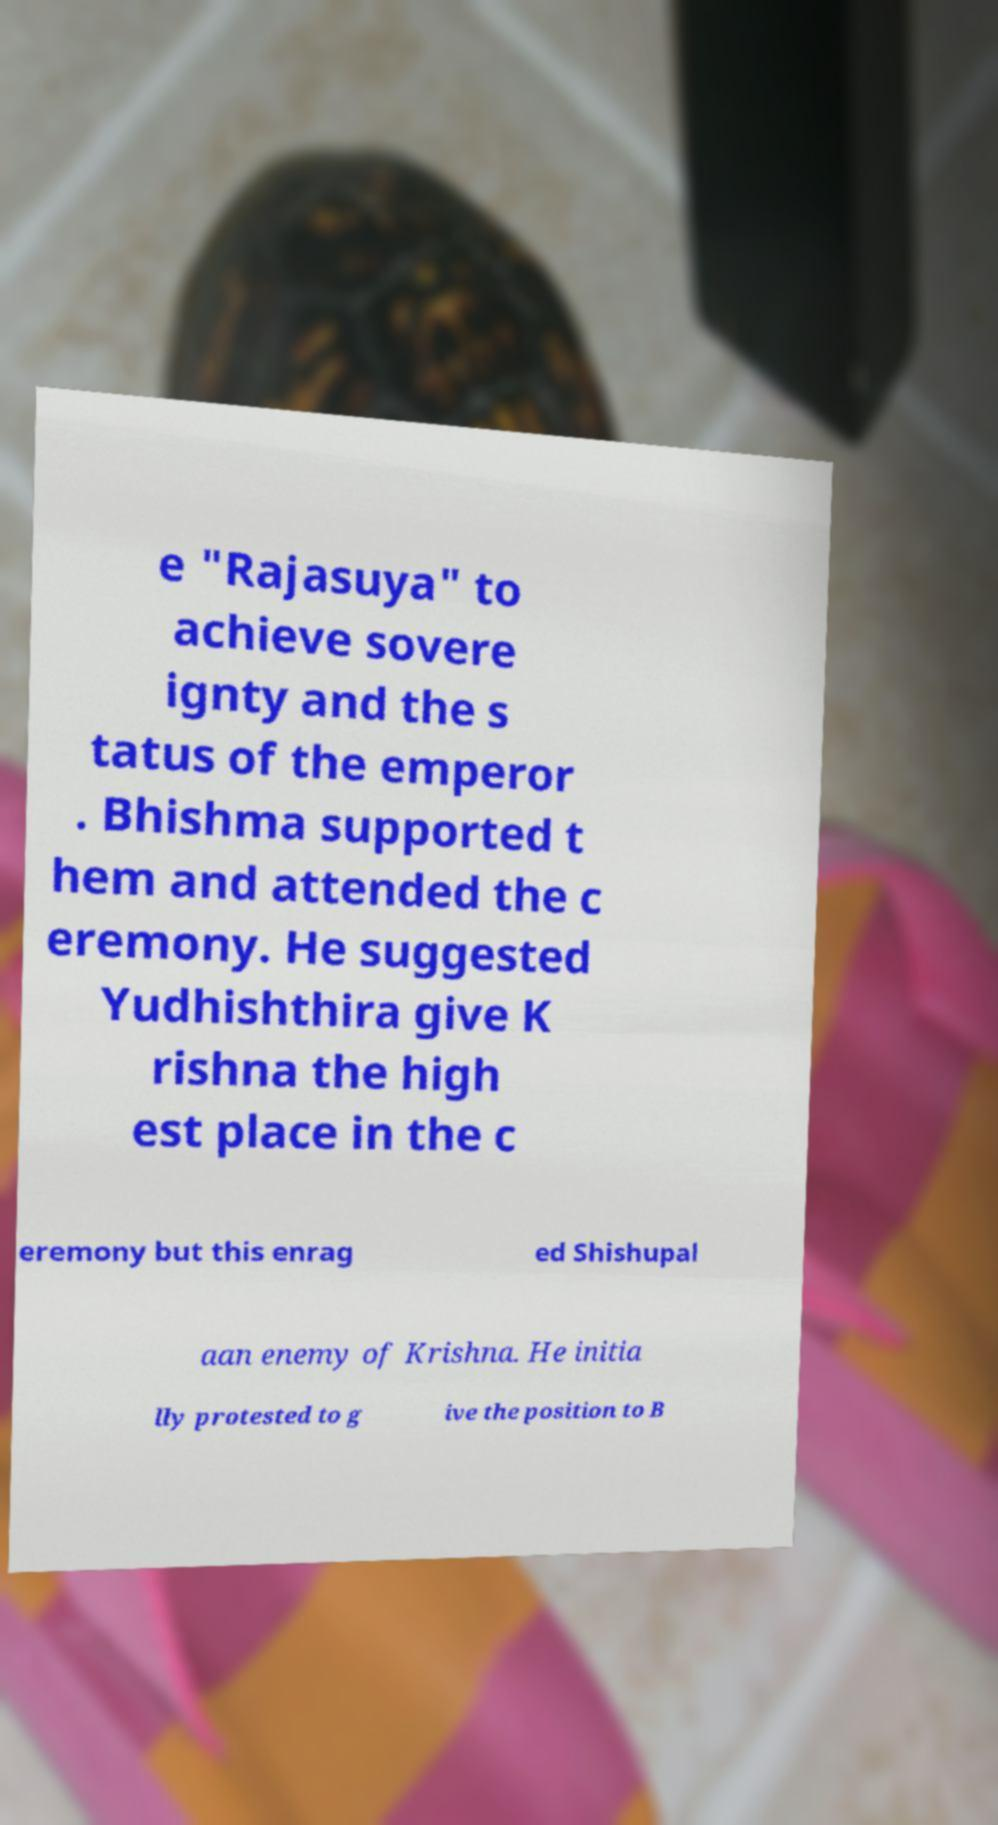I need the written content from this picture converted into text. Can you do that? e "Rajasuya" to achieve sovere ignty and the s tatus of the emperor . Bhishma supported t hem and attended the c eremony. He suggested Yudhishthira give K rishna the high est place in the c eremony but this enrag ed Shishupal aan enemy of Krishna. He initia lly protested to g ive the position to B 